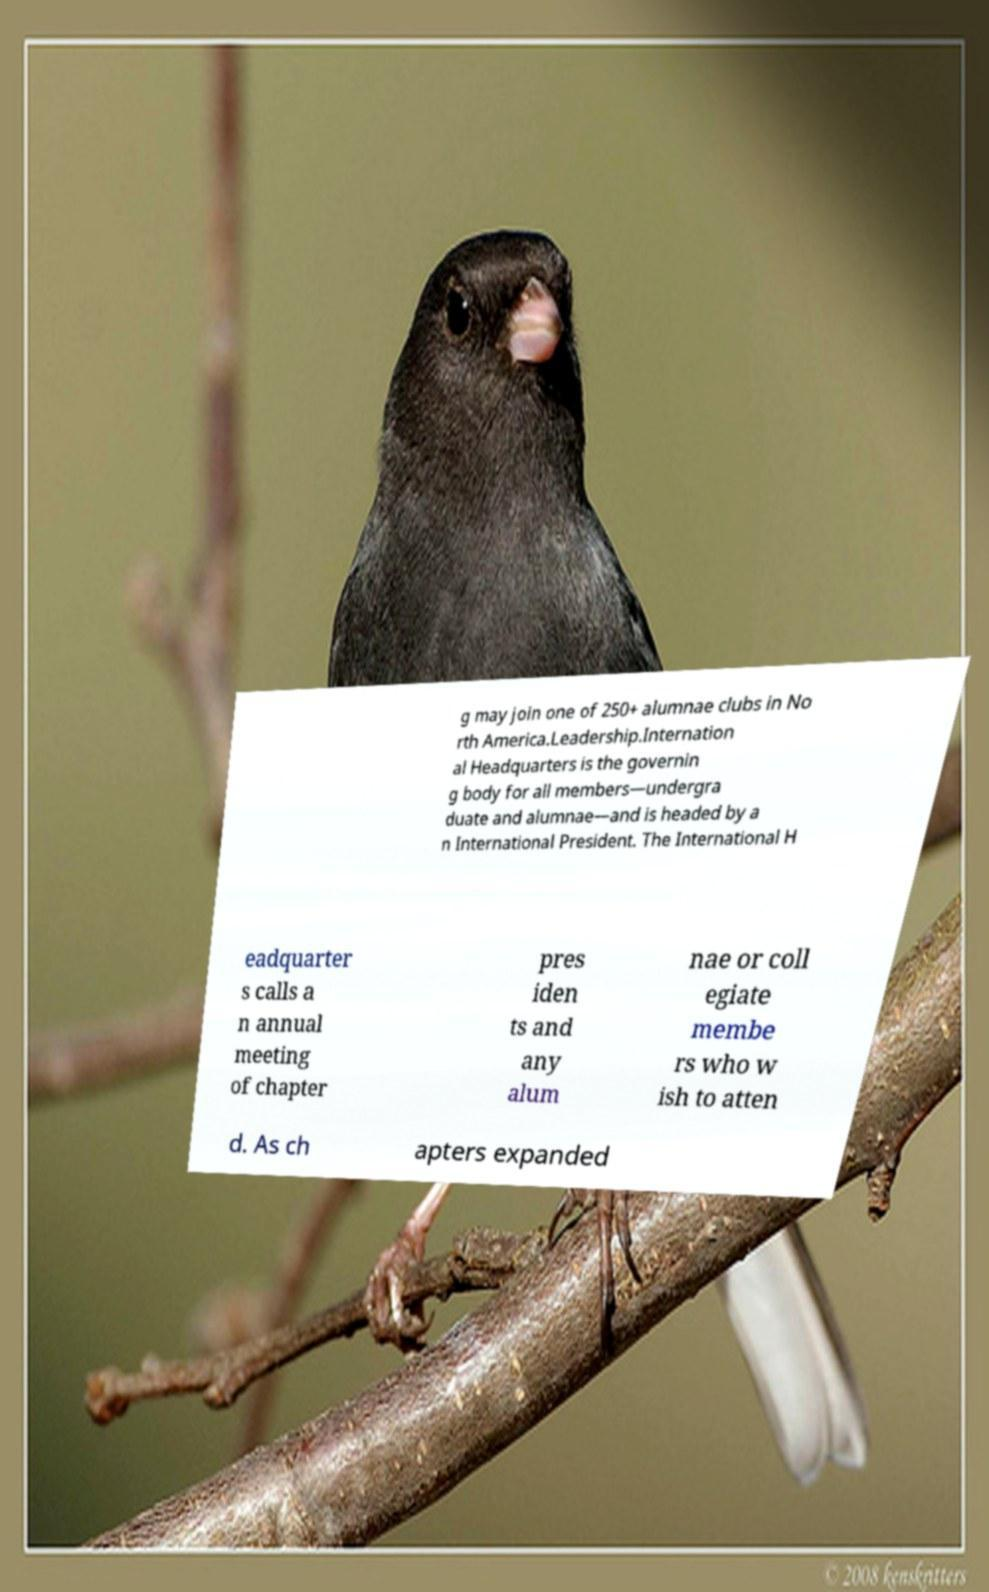Could you extract and type out the text from this image? g may join one of 250+ alumnae clubs in No rth America.Leadership.Internation al Headquarters is the governin g body for all members—undergra duate and alumnae—and is headed by a n International President. The International H eadquarter s calls a n annual meeting of chapter pres iden ts and any alum nae or coll egiate membe rs who w ish to atten d. As ch apters expanded 